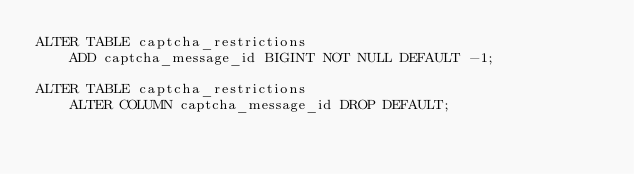Convert code to text. <code><loc_0><loc_0><loc_500><loc_500><_SQL_>ALTER TABLE captcha_restrictions
    ADD captcha_message_id BIGINT NOT NULL DEFAULT -1;

ALTER TABLE captcha_restrictions
    ALTER COLUMN captcha_message_id DROP DEFAULT;

</code> 